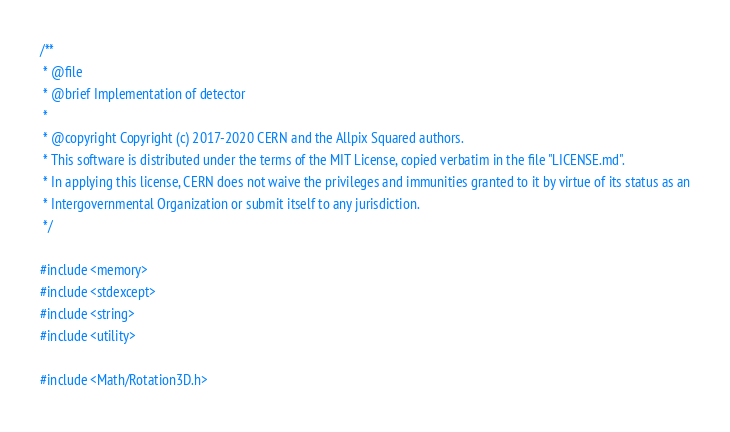<code> <loc_0><loc_0><loc_500><loc_500><_C++_>/**
 * @file
 * @brief Implementation of detector
 *
 * @copyright Copyright (c) 2017-2020 CERN and the Allpix Squared authors.
 * This software is distributed under the terms of the MIT License, copied verbatim in the file "LICENSE.md".
 * In applying this license, CERN does not waive the privileges and immunities granted to it by virtue of its status as an
 * Intergovernmental Organization or submit itself to any jurisdiction.
 */

#include <memory>
#include <stdexcept>
#include <string>
#include <utility>

#include <Math/Rotation3D.h></code> 